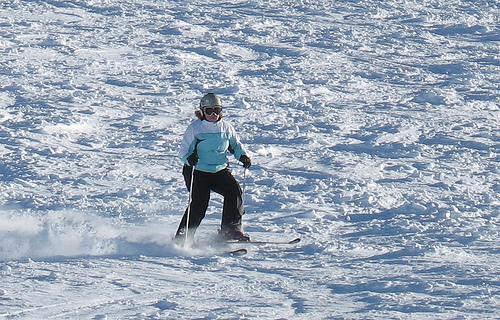Is the child behind the adult?
Keep it brief. No. Are there any sponsorships?
Keep it brief. No. Is she going very fast?
Write a very short answer. No. What color jacket does the adult have on?
Short answer required. Blue. Is the woman wearing ski goggles?
Write a very short answer. Yes. What is the white stuff on the ground?
Write a very short answer. Snow. What is the person holding?
Answer briefly. Ski poles. 